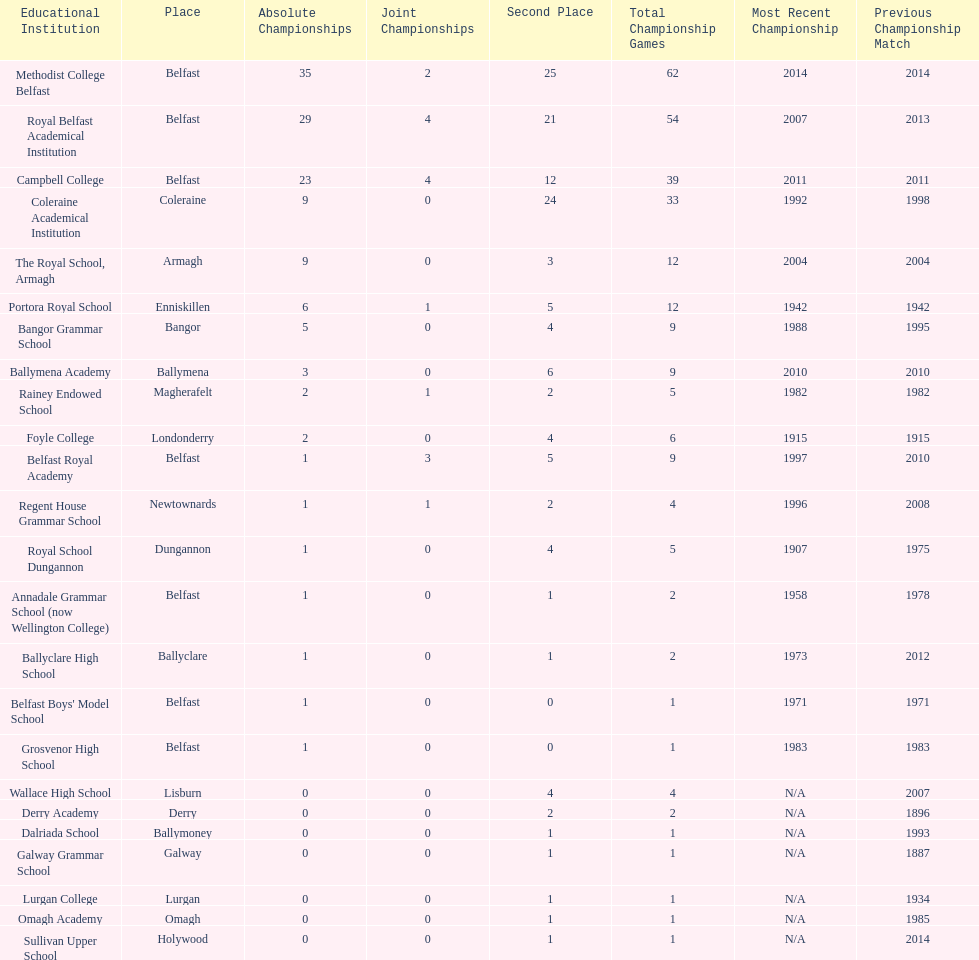How many schools have had at least 3 share titles? 3. 